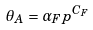Convert formula to latex. <formula><loc_0><loc_0><loc_500><loc_500>\theta _ { A } = \alpha _ { F } p ^ { C _ { F } }</formula> 